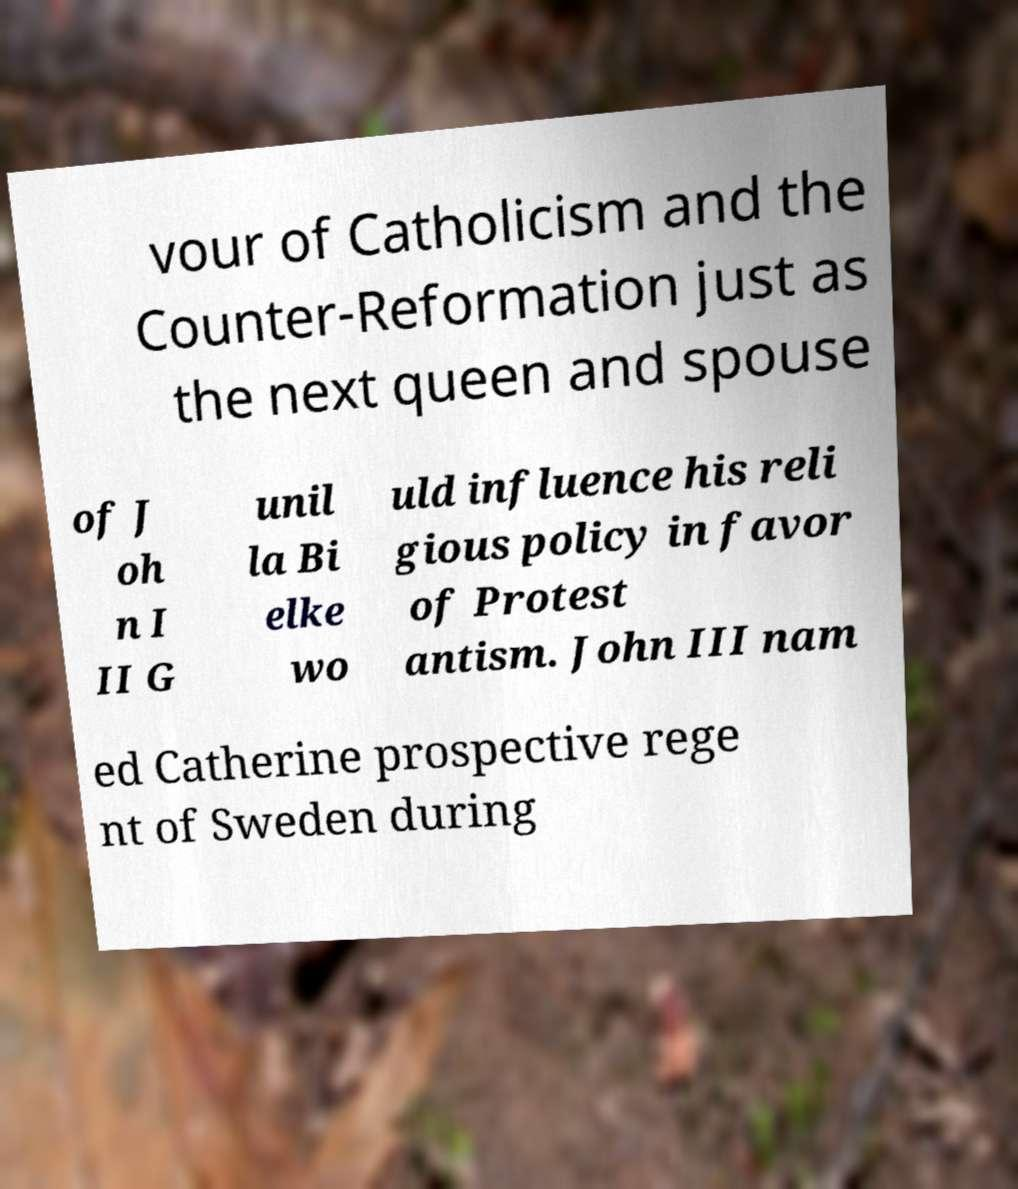Please read and relay the text visible in this image. What does it say? vour of Catholicism and the Counter-Reformation just as the next queen and spouse of J oh n I II G unil la Bi elke wo uld influence his reli gious policy in favor of Protest antism. John III nam ed Catherine prospective rege nt of Sweden during 